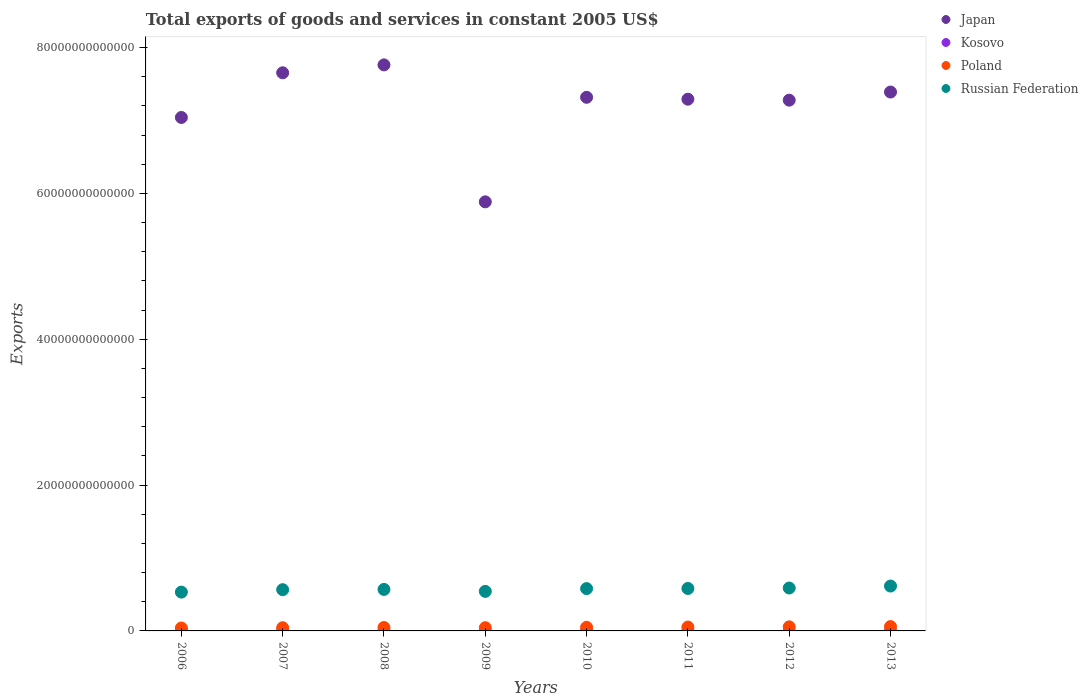What is the total exports of goods and services in Poland in 2009?
Ensure brevity in your answer.  4.40e+11. Across all years, what is the maximum total exports of goods and services in Poland?
Provide a succinct answer. 5.94e+11. Across all years, what is the minimum total exports of goods and services in Kosovo?
Offer a very short reply. 4.81e+08. In which year was the total exports of goods and services in Japan maximum?
Your answer should be very brief. 2008. In which year was the total exports of goods and services in Kosovo minimum?
Keep it short and to the point. 2006. What is the total total exports of goods and services in Russian Federation in the graph?
Make the answer very short. 4.58e+13. What is the difference between the total exports of goods and services in Japan in 2007 and that in 2009?
Give a very brief answer. 1.77e+13. What is the difference between the total exports of goods and services in Japan in 2006 and the total exports of goods and services in Russian Federation in 2010?
Your response must be concise. 6.46e+13. What is the average total exports of goods and services in Poland per year?
Offer a very short reply. 4.91e+11. In the year 2007, what is the difference between the total exports of goods and services in Japan and total exports of goods and services in Russian Federation?
Ensure brevity in your answer.  7.09e+13. In how many years, is the total exports of goods and services in Kosovo greater than 16000000000000 US$?
Offer a very short reply. 0. What is the ratio of the total exports of goods and services in Poland in 2007 to that in 2008?
Keep it short and to the point. 0.93. Is the total exports of goods and services in Poland in 2009 less than that in 2013?
Provide a short and direct response. Yes. Is the difference between the total exports of goods and services in Japan in 2008 and 2011 greater than the difference between the total exports of goods and services in Russian Federation in 2008 and 2011?
Your answer should be compact. Yes. What is the difference between the highest and the second highest total exports of goods and services in Poland?
Offer a very short reply. 3.41e+1. What is the difference between the highest and the lowest total exports of goods and services in Japan?
Make the answer very short. 1.88e+13. Is the sum of the total exports of goods and services in Poland in 2006 and 2013 greater than the maximum total exports of goods and services in Japan across all years?
Ensure brevity in your answer.  No. Is it the case that in every year, the sum of the total exports of goods and services in Japan and total exports of goods and services in Poland  is greater than the sum of total exports of goods and services in Russian Federation and total exports of goods and services in Kosovo?
Your answer should be compact. Yes. How many years are there in the graph?
Ensure brevity in your answer.  8. What is the difference between two consecutive major ticks on the Y-axis?
Your answer should be compact. 2.00e+13. Are the values on the major ticks of Y-axis written in scientific E-notation?
Ensure brevity in your answer.  No. Does the graph contain any zero values?
Keep it short and to the point. No. Where does the legend appear in the graph?
Keep it short and to the point. Top right. How many legend labels are there?
Keep it short and to the point. 4. How are the legend labels stacked?
Your answer should be very brief. Vertical. What is the title of the graph?
Keep it short and to the point. Total exports of goods and services in constant 2005 US$. What is the label or title of the X-axis?
Make the answer very short. Years. What is the label or title of the Y-axis?
Your response must be concise. Exports. What is the Exports of Japan in 2006?
Your answer should be very brief. 7.04e+13. What is the Exports of Kosovo in 2006?
Provide a succinct answer. 4.81e+08. What is the Exports of Poland in 2006?
Provide a succinct answer. 3.98e+11. What is the Exports of Russian Federation in 2006?
Provide a succinct answer. 5.32e+12. What is the Exports in Japan in 2007?
Your answer should be compact. 7.65e+13. What is the Exports in Kosovo in 2007?
Your answer should be very brief. 6.08e+08. What is the Exports of Poland in 2007?
Offer a terse response. 4.38e+11. What is the Exports in Russian Federation in 2007?
Offer a very short reply. 5.66e+12. What is the Exports of Japan in 2008?
Offer a terse response. 7.76e+13. What is the Exports in Kosovo in 2008?
Offer a very short reply. 6.09e+08. What is the Exports of Poland in 2008?
Offer a terse response. 4.69e+11. What is the Exports of Russian Federation in 2008?
Offer a very short reply. 5.69e+12. What is the Exports of Japan in 2009?
Offer a terse response. 5.88e+13. What is the Exports of Kosovo in 2009?
Provide a succinct answer. 6.85e+08. What is the Exports in Poland in 2009?
Your response must be concise. 4.40e+11. What is the Exports in Russian Federation in 2009?
Provide a succinct answer. 5.42e+12. What is the Exports of Japan in 2010?
Give a very brief answer. 7.32e+13. What is the Exports in Kosovo in 2010?
Give a very brief answer. 7.70e+08. What is the Exports in Poland in 2010?
Make the answer very short. 4.96e+11. What is the Exports of Russian Federation in 2010?
Offer a terse response. 5.80e+12. What is the Exports of Japan in 2011?
Your response must be concise. 7.29e+13. What is the Exports of Kosovo in 2011?
Provide a short and direct response. 8.00e+08. What is the Exports in Poland in 2011?
Provide a succinct answer. 5.35e+11. What is the Exports in Russian Federation in 2011?
Make the answer very short. 5.82e+12. What is the Exports in Japan in 2012?
Ensure brevity in your answer.  7.28e+13. What is the Exports in Kosovo in 2012?
Give a very brief answer. 8.06e+08. What is the Exports of Poland in 2012?
Provide a short and direct response. 5.60e+11. What is the Exports in Russian Federation in 2012?
Provide a succinct answer. 5.88e+12. What is the Exports of Japan in 2013?
Keep it short and to the point. 7.39e+13. What is the Exports of Kosovo in 2013?
Keep it short and to the point. 8.24e+08. What is the Exports in Poland in 2013?
Give a very brief answer. 5.94e+11. What is the Exports of Russian Federation in 2013?
Offer a terse response. 6.16e+12. Across all years, what is the maximum Exports of Japan?
Offer a very short reply. 7.76e+13. Across all years, what is the maximum Exports of Kosovo?
Offer a terse response. 8.24e+08. Across all years, what is the maximum Exports in Poland?
Your response must be concise. 5.94e+11. Across all years, what is the maximum Exports in Russian Federation?
Provide a succinct answer. 6.16e+12. Across all years, what is the minimum Exports in Japan?
Ensure brevity in your answer.  5.88e+13. Across all years, what is the minimum Exports of Kosovo?
Provide a short and direct response. 4.81e+08. Across all years, what is the minimum Exports in Poland?
Provide a succinct answer. 3.98e+11. Across all years, what is the minimum Exports of Russian Federation?
Your answer should be very brief. 5.32e+12. What is the total Exports of Japan in the graph?
Keep it short and to the point. 5.76e+14. What is the total Exports in Kosovo in the graph?
Keep it short and to the point. 5.58e+09. What is the total Exports in Poland in the graph?
Offer a terse response. 3.93e+12. What is the total Exports of Russian Federation in the graph?
Offer a very short reply. 4.58e+13. What is the difference between the Exports of Japan in 2006 and that in 2007?
Ensure brevity in your answer.  -6.13e+12. What is the difference between the Exports of Kosovo in 2006 and that in 2007?
Ensure brevity in your answer.  -1.27e+08. What is the difference between the Exports in Poland in 2006 and that in 2007?
Provide a short and direct response. -4.05e+1. What is the difference between the Exports in Russian Federation in 2006 and that in 2007?
Provide a succinct answer. -3.35e+11. What is the difference between the Exports in Japan in 2006 and that in 2008?
Provide a succinct answer. -7.21e+12. What is the difference between the Exports in Kosovo in 2006 and that in 2008?
Provide a short and direct response. -1.28e+08. What is the difference between the Exports of Poland in 2006 and that in 2008?
Your answer should be very brief. -7.13e+1. What is the difference between the Exports of Russian Federation in 2006 and that in 2008?
Give a very brief answer. -3.69e+11. What is the difference between the Exports in Japan in 2006 and that in 2009?
Make the answer very short. 1.16e+13. What is the difference between the Exports in Kosovo in 2006 and that in 2009?
Offer a terse response. -2.03e+08. What is the difference between the Exports of Poland in 2006 and that in 2009?
Provide a succinct answer. -4.18e+1. What is the difference between the Exports in Russian Federation in 2006 and that in 2009?
Your response must be concise. -1.02e+11. What is the difference between the Exports in Japan in 2006 and that in 2010?
Your answer should be compact. -2.76e+12. What is the difference between the Exports of Kosovo in 2006 and that in 2010?
Offer a very short reply. -2.89e+08. What is the difference between the Exports in Poland in 2006 and that in 2010?
Give a very brief answer. -9.83e+1. What is the difference between the Exports in Russian Federation in 2006 and that in 2010?
Your answer should be very brief. -4.81e+11. What is the difference between the Exports of Japan in 2006 and that in 2011?
Provide a succinct answer. -2.50e+12. What is the difference between the Exports of Kosovo in 2006 and that in 2011?
Your answer should be compact. -3.19e+08. What is the difference between the Exports of Poland in 2006 and that in 2011?
Your response must be concise. -1.37e+11. What is the difference between the Exports in Russian Federation in 2006 and that in 2011?
Provide a succinct answer. -4.99e+11. What is the difference between the Exports in Japan in 2006 and that in 2012?
Offer a very short reply. -2.37e+12. What is the difference between the Exports in Kosovo in 2006 and that in 2012?
Give a very brief answer. -3.24e+08. What is the difference between the Exports in Poland in 2006 and that in 2012?
Your answer should be very brief. -1.62e+11. What is the difference between the Exports in Russian Federation in 2006 and that in 2012?
Provide a succinct answer. -5.63e+11. What is the difference between the Exports in Japan in 2006 and that in 2013?
Your answer should be compact. -3.49e+12. What is the difference between the Exports of Kosovo in 2006 and that in 2013?
Your answer should be compact. -3.43e+08. What is the difference between the Exports in Poland in 2006 and that in 2013?
Offer a terse response. -1.96e+11. What is the difference between the Exports in Russian Federation in 2006 and that in 2013?
Give a very brief answer. -8.34e+11. What is the difference between the Exports of Japan in 2007 and that in 2008?
Offer a terse response. -1.08e+12. What is the difference between the Exports of Kosovo in 2007 and that in 2008?
Give a very brief answer. -5.00e+05. What is the difference between the Exports in Poland in 2007 and that in 2008?
Ensure brevity in your answer.  -3.07e+1. What is the difference between the Exports of Russian Federation in 2007 and that in 2008?
Your answer should be very brief. -3.39e+1. What is the difference between the Exports in Japan in 2007 and that in 2009?
Offer a terse response. 1.77e+13. What is the difference between the Exports of Kosovo in 2007 and that in 2009?
Give a very brief answer. -7.64e+07. What is the difference between the Exports of Poland in 2007 and that in 2009?
Keep it short and to the point. -1.27e+09. What is the difference between the Exports of Russian Federation in 2007 and that in 2009?
Provide a succinct answer. 2.34e+11. What is the difference between the Exports in Japan in 2007 and that in 2010?
Provide a short and direct response. 3.36e+12. What is the difference between the Exports of Kosovo in 2007 and that in 2010?
Your response must be concise. -1.62e+08. What is the difference between the Exports in Poland in 2007 and that in 2010?
Your response must be concise. -5.78e+1. What is the difference between the Exports in Russian Federation in 2007 and that in 2010?
Provide a short and direct response. -1.46e+11. What is the difference between the Exports of Japan in 2007 and that in 2011?
Your answer should be compact. 3.62e+12. What is the difference between the Exports of Kosovo in 2007 and that in 2011?
Give a very brief answer. -1.92e+08. What is the difference between the Exports in Poland in 2007 and that in 2011?
Your answer should be very brief. -9.68e+1. What is the difference between the Exports in Russian Federation in 2007 and that in 2011?
Give a very brief answer. -1.64e+11. What is the difference between the Exports in Japan in 2007 and that in 2012?
Ensure brevity in your answer.  3.75e+12. What is the difference between the Exports in Kosovo in 2007 and that in 2012?
Your answer should be very brief. -1.97e+08. What is the difference between the Exports of Poland in 2007 and that in 2012?
Offer a terse response. -1.21e+11. What is the difference between the Exports of Russian Federation in 2007 and that in 2012?
Make the answer very short. -2.28e+11. What is the difference between the Exports of Japan in 2007 and that in 2013?
Offer a terse response. 2.64e+12. What is the difference between the Exports in Kosovo in 2007 and that in 2013?
Offer a terse response. -2.16e+08. What is the difference between the Exports in Poland in 2007 and that in 2013?
Offer a very short reply. -1.55e+11. What is the difference between the Exports in Russian Federation in 2007 and that in 2013?
Provide a succinct answer. -4.98e+11. What is the difference between the Exports in Japan in 2008 and that in 2009?
Ensure brevity in your answer.  1.88e+13. What is the difference between the Exports of Kosovo in 2008 and that in 2009?
Provide a succinct answer. -7.59e+07. What is the difference between the Exports in Poland in 2008 and that in 2009?
Your answer should be compact. 2.95e+1. What is the difference between the Exports of Russian Federation in 2008 and that in 2009?
Provide a succinct answer. 2.67e+11. What is the difference between the Exports of Japan in 2008 and that in 2010?
Your answer should be compact. 4.45e+12. What is the difference between the Exports of Kosovo in 2008 and that in 2010?
Make the answer very short. -1.62e+08. What is the difference between the Exports of Poland in 2008 and that in 2010?
Give a very brief answer. -2.71e+1. What is the difference between the Exports in Russian Federation in 2008 and that in 2010?
Make the answer very short. -1.12e+11. What is the difference between the Exports in Japan in 2008 and that in 2011?
Your response must be concise. 4.71e+12. What is the difference between the Exports of Kosovo in 2008 and that in 2011?
Provide a short and direct response. -1.91e+08. What is the difference between the Exports of Poland in 2008 and that in 2011?
Give a very brief answer. -6.61e+1. What is the difference between the Exports in Russian Federation in 2008 and that in 2011?
Provide a succinct answer. -1.30e+11. What is the difference between the Exports of Japan in 2008 and that in 2012?
Provide a short and direct response. 4.84e+12. What is the difference between the Exports in Kosovo in 2008 and that in 2012?
Offer a terse response. -1.97e+08. What is the difference between the Exports of Poland in 2008 and that in 2012?
Your answer should be very brief. -9.06e+1. What is the difference between the Exports of Russian Federation in 2008 and that in 2012?
Offer a very short reply. -1.94e+11. What is the difference between the Exports in Japan in 2008 and that in 2013?
Your answer should be compact. 3.72e+12. What is the difference between the Exports of Kosovo in 2008 and that in 2013?
Your answer should be compact. -2.15e+08. What is the difference between the Exports of Poland in 2008 and that in 2013?
Your response must be concise. -1.25e+11. What is the difference between the Exports in Russian Federation in 2008 and that in 2013?
Offer a very short reply. -4.64e+11. What is the difference between the Exports of Japan in 2009 and that in 2010?
Offer a very short reply. -1.43e+13. What is the difference between the Exports of Kosovo in 2009 and that in 2010?
Ensure brevity in your answer.  -8.56e+07. What is the difference between the Exports of Poland in 2009 and that in 2010?
Your answer should be compact. -5.65e+1. What is the difference between the Exports in Russian Federation in 2009 and that in 2010?
Ensure brevity in your answer.  -3.80e+11. What is the difference between the Exports of Japan in 2009 and that in 2011?
Your response must be concise. -1.41e+13. What is the difference between the Exports in Kosovo in 2009 and that in 2011?
Provide a short and direct response. -1.15e+08. What is the difference between the Exports of Poland in 2009 and that in 2011?
Make the answer very short. -9.55e+1. What is the difference between the Exports in Russian Federation in 2009 and that in 2011?
Your answer should be very brief. -3.97e+11. What is the difference between the Exports of Japan in 2009 and that in 2012?
Make the answer very short. -1.39e+13. What is the difference between the Exports of Kosovo in 2009 and that in 2012?
Provide a short and direct response. -1.21e+08. What is the difference between the Exports in Poland in 2009 and that in 2012?
Ensure brevity in your answer.  -1.20e+11. What is the difference between the Exports in Russian Federation in 2009 and that in 2012?
Give a very brief answer. -4.61e+11. What is the difference between the Exports of Japan in 2009 and that in 2013?
Keep it short and to the point. -1.51e+13. What is the difference between the Exports of Kosovo in 2009 and that in 2013?
Your response must be concise. -1.39e+08. What is the difference between the Exports of Poland in 2009 and that in 2013?
Provide a short and direct response. -1.54e+11. What is the difference between the Exports of Russian Federation in 2009 and that in 2013?
Offer a very short reply. -7.32e+11. What is the difference between the Exports of Japan in 2010 and that in 2011?
Your answer should be very brief. 2.60e+11. What is the difference between the Exports in Kosovo in 2010 and that in 2011?
Provide a short and direct response. -2.96e+07. What is the difference between the Exports of Poland in 2010 and that in 2011?
Ensure brevity in your answer.  -3.90e+1. What is the difference between the Exports of Russian Federation in 2010 and that in 2011?
Your answer should be compact. -1.74e+1. What is the difference between the Exports of Japan in 2010 and that in 2012?
Provide a succinct answer. 3.92e+11. What is the difference between the Exports in Kosovo in 2010 and that in 2012?
Provide a short and direct response. -3.52e+07. What is the difference between the Exports in Poland in 2010 and that in 2012?
Make the answer very short. -6.35e+1. What is the difference between the Exports in Russian Federation in 2010 and that in 2012?
Offer a very short reply. -8.14e+1. What is the difference between the Exports in Japan in 2010 and that in 2013?
Provide a short and direct response. -7.21e+11. What is the difference between the Exports of Kosovo in 2010 and that in 2013?
Offer a very short reply. -5.38e+07. What is the difference between the Exports of Poland in 2010 and that in 2013?
Your answer should be very brief. -9.76e+1. What is the difference between the Exports of Russian Federation in 2010 and that in 2013?
Offer a terse response. -3.52e+11. What is the difference between the Exports in Japan in 2011 and that in 2012?
Your answer should be very brief. 1.32e+11. What is the difference between the Exports of Kosovo in 2011 and that in 2012?
Ensure brevity in your answer.  -5.60e+06. What is the difference between the Exports of Poland in 2011 and that in 2012?
Give a very brief answer. -2.45e+1. What is the difference between the Exports in Russian Federation in 2011 and that in 2012?
Give a very brief answer. -6.40e+1. What is the difference between the Exports of Japan in 2011 and that in 2013?
Your response must be concise. -9.81e+11. What is the difference between the Exports in Kosovo in 2011 and that in 2013?
Offer a very short reply. -2.42e+07. What is the difference between the Exports in Poland in 2011 and that in 2013?
Your answer should be very brief. -5.86e+1. What is the difference between the Exports of Russian Federation in 2011 and that in 2013?
Your answer should be very brief. -3.35e+11. What is the difference between the Exports of Japan in 2012 and that in 2013?
Give a very brief answer. -1.11e+12. What is the difference between the Exports of Kosovo in 2012 and that in 2013?
Offer a terse response. -1.86e+07. What is the difference between the Exports in Poland in 2012 and that in 2013?
Your answer should be compact. -3.41e+1. What is the difference between the Exports of Russian Federation in 2012 and that in 2013?
Provide a succinct answer. -2.71e+11. What is the difference between the Exports of Japan in 2006 and the Exports of Kosovo in 2007?
Keep it short and to the point. 7.04e+13. What is the difference between the Exports of Japan in 2006 and the Exports of Poland in 2007?
Offer a very short reply. 7.00e+13. What is the difference between the Exports of Japan in 2006 and the Exports of Russian Federation in 2007?
Your answer should be compact. 6.48e+13. What is the difference between the Exports of Kosovo in 2006 and the Exports of Poland in 2007?
Your answer should be very brief. -4.38e+11. What is the difference between the Exports in Kosovo in 2006 and the Exports in Russian Federation in 2007?
Keep it short and to the point. -5.66e+12. What is the difference between the Exports in Poland in 2006 and the Exports in Russian Federation in 2007?
Give a very brief answer. -5.26e+12. What is the difference between the Exports of Japan in 2006 and the Exports of Kosovo in 2008?
Your answer should be very brief. 7.04e+13. What is the difference between the Exports of Japan in 2006 and the Exports of Poland in 2008?
Give a very brief answer. 6.99e+13. What is the difference between the Exports of Japan in 2006 and the Exports of Russian Federation in 2008?
Keep it short and to the point. 6.47e+13. What is the difference between the Exports in Kosovo in 2006 and the Exports in Poland in 2008?
Make the answer very short. -4.69e+11. What is the difference between the Exports in Kosovo in 2006 and the Exports in Russian Federation in 2008?
Make the answer very short. -5.69e+12. What is the difference between the Exports in Poland in 2006 and the Exports in Russian Federation in 2008?
Provide a succinct answer. -5.29e+12. What is the difference between the Exports in Japan in 2006 and the Exports in Kosovo in 2009?
Provide a short and direct response. 7.04e+13. What is the difference between the Exports in Japan in 2006 and the Exports in Poland in 2009?
Provide a succinct answer. 7.00e+13. What is the difference between the Exports of Japan in 2006 and the Exports of Russian Federation in 2009?
Offer a very short reply. 6.50e+13. What is the difference between the Exports in Kosovo in 2006 and the Exports in Poland in 2009?
Offer a terse response. -4.39e+11. What is the difference between the Exports in Kosovo in 2006 and the Exports in Russian Federation in 2009?
Keep it short and to the point. -5.42e+12. What is the difference between the Exports in Poland in 2006 and the Exports in Russian Federation in 2009?
Your answer should be compact. -5.03e+12. What is the difference between the Exports in Japan in 2006 and the Exports in Kosovo in 2010?
Give a very brief answer. 7.04e+13. What is the difference between the Exports of Japan in 2006 and the Exports of Poland in 2010?
Keep it short and to the point. 6.99e+13. What is the difference between the Exports of Japan in 2006 and the Exports of Russian Federation in 2010?
Provide a succinct answer. 6.46e+13. What is the difference between the Exports in Kosovo in 2006 and the Exports in Poland in 2010?
Your response must be concise. -4.96e+11. What is the difference between the Exports in Kosovo in 2006 and the Exports in Russian Federation in 2010?
Provide a succinct answer. -5.80e+12. What is the difference between the Exports of Poland in 2006 and the Exports of Russian Federation in 2010?
Keep it short and to the point. -5.41e+12. What is the difference between the Exports in Japan in 2006 and the Exports in Kosovo in 2011?
Make the answer very short. 7.04e+13. What is the difference between the Exports in Japan in 2006 and the Exports in Poland in 2011?
Offer a very short reply. 6.99e+13. What is the difference between the Exports of Japan in 2006 and the Exports of Russian Federation in 2011?
Provide a succinct answer. 6.46e+13. What is the difference between the Exports of Kosovo in 2006 and the Exports of Poland in 2011?
Your answer should be compact. -5.35e+11. What is the difference between the Exports of Kosovo in 2006 and the Exports of Russian Federation in 2011?
Your answer should be very brief. -5.82e+12. What is the difference between the Exports of Poland in 2006 and the Exports of Russian Federation in 2011?
Provide a succinct answer. -5.42e+12. What is the difference between the Exports in Japan in 2006 and the Exports in Kosovo in 2012?
Offer a terse response. 7.04e+13. What is the difference between the Exports in Japan in 2006 and the Exports in Poland in 2012?
Your answer should be compact. 6.99e+13. What is the difference between the Exports in Japan in 2006 and the Exports in Russian Federation in 2012?
Make the answer very short. 6.45e+13. What is the difference between the Exports in Kosovo in 2006 and the Exports in Poland in 2012?
Ensure brevity in your answer.  -5.59e+11. What is the difference between the Exports in Kosovo in 2006 and the Exports in Russian Federation in 2012?
Your answer should be very brief. -5.88e+12. What is the difference between the Exports in Poland in 2006 and the Exports in Russian Federation in 2012?
Your answer should be compact. -5.49e+12. What is the difference between the Exports in Japan in 2006 and the Exports in Kosovo in 2013?
Provide a succinct answer. 7.04e+13. What is the difference between the Exports of Japan in 2006 and the Exports of Poland in 2013?
Keep it short and to the point. 6.98e+13. What is the difference between the Exports in Japan in 2006 and the Exports in Russian Federation in 2013?
Make the answer very short. 6.43e+13. What is the difference between the Exports of Kosovo in 2006 and the Exports of Poland in 2013?
Make the answer very short. -5.93e+11. What is the difference between the Exports of Kosovo in 2006 and the Exports of Russian Federation in 2013?
Provide a short and direct response. -6.16e+12. What is the difference between the Exports in Poland in 2006 and the Exports in Russian Federation in 2013?
Provide a succinct answer. -5.76e+12. What is the difference between the Exports in Japan in 2007 and the Exports in Kosovo in 2008?
Keep it short and to the point. 7.65e+13. What is the difference between the Exports of Japan in 2007 and the Exports of Poland in 2008?
Ensure brevity in your answer.  7.61e+13. What is the difference between the Exports in Japan in 2007 and the Exports in Russian Federation in 2008?
Keep it short and to the point. 7.09e+13. What is the difference between the Exports in Kosovo in 2007 and the Exports in Poland in 2008?
Provide a succinct answer. -4.68e+11. What is the difference between the Exports in Kosovo in 2007 and the Exports in Russian Federation in 2008?
Your answer should be very brief. -5.69e+12. What is the difference between the Exports in Poland in 2007 and the Exports in Russian Federation in 2008?
Provide a succinct answer. -5.25e+12. What is the difference between the Exports in Japan in 2007 and the Exports in Kosovo in 2009?
Ensure brevity in your answer.  7.65e+13. What is the difference between the Exports of Japan in 2007 and the Exports of Poland in 2009?
Give a very brief answer. 7.61e+13. What is the difference between the Exports of Japan in 2007 and the Exports of Russian Federation in 2009?
Offer a very short reply. 7.11e+13. What is the difference between the Exports of Kosovo in 2007 and the Exports of Poland in 2009?
Ensure brevity in your answer.  -4.39e+11. What is the difference between the Exports in Kosovo in 2007 and the Exports in Russian Federation in 2009?
Keep it short and to the point. -5.42e+12. What is the difference between the Exports of Poland in 2007 and the Exports of Russian Federation in 2009?
Your answer should be very brief. -4.99e+12. What is the difference between the Exports in Japan in 2007 and the Exports in Kosovo in 2010?
Offer a very short reply. 7.65e+13. What is the difference between the Exports of Japan in 2007 and the Exports of Poland in 2010?
Your answer should be very brief. 7.60e+13. What is the difference between the Exports in Japan in 2007 and the Exports in Russian Federation in 2010?
Ensure brevity in your answer.  7.07e+13. What is the difference between the Exports in Kosovo in 2007 and the Exports in Poland in 2010?
Give a very brief answer. -4.95e+11. What is the difference between the Exports in Kosovo in 2007 and the Exports in Russian Federation in 2010?
Your answer should be compact. -5.80e+12. What is the difference between the Exports of Poland in 2007 and the Exports of Russian Federation in 2010?
Keep it short and to the point. -5.37e+12. What is the difference between the Exports in Japan in 2007 and the Exports in Kosovo in 2011?
Offer a very short reply. 7.65e+13. What is the difference between the Exports in Japan in 2007 and the Exports in Poland in 2011?
Offer a terse response. 7.60e+13. What is the difference between the Exports of Japan in 2007 and the Exports of Russian Federation in 2011?
Offer a very short reply. 7.07e+13. What is the difference between the Exports of Kosovo in 2007 and the Exports of Poland in 2011?
Your answer should be very brief. -5.34e+11. What is the difference between the Exports of Kosovo in 2007 and the Exports of Russian Federation in 2011?
Offer a very short reply. -5.82e+12. What is the difference between the Exports in Poland in 2007 and the Exports in Russian Federation in 2011?
Ensure brevity in your answer.  -5.38e+12. What is the difference between the Exports of Japan in 2007 and the Exports of Kosovo in 2012?
Offer a terse response. 7.65e+13. What is the difference between the Exports of Japan in 2007 and the Exports of Poland in 2012?
Your response must be concise. 7.60e+13. What is the difference between the Exports in Japan in 2007 and the Exports in Russian Federation in 2012?
Give a very brief answer. 7.07e+13. What is the difference between the Exports of Kosovo in 2007 and the Exports of Poland in 2012?
Offer a terse response. -5.59e+11. What is the difference between the Exports in Kosovo in 2007 and the Exports in Russian Federation in 2012?
Your response must be concise. -5.88e+12. What is the difference between the Exports in Poland in 2007 and the Exports in Russian Federation in 2012?
Provide a short and direct response. -5.45e+12. What is the difference between the Exports in Japan in 2007 and the Exports in Kosovo in 2013?
Your answer should be very brief. 7.65e+13. What is the difference between the Exports of Japan in 2007 and the Exports of Poland in 2013?
Your response must be concise. 7.60e+13. What is the difference between the Exports of Japan in 2007 and the Exports of Russian Federation in 2013?
Give a very brief answer. 7.04e+13. What is the difference between the Exports of Kosovo in 2007 and the Exports of Poland in 2013?
Provide a short and direct response. -5.93e+11. What is the difference between the Exports of Kosovo in 2007 and the Exports of Russian Federation in 2013?
Offer a very short reply. -6.16e+12. What is the difference between the Exports of Poland in 2007 and the Exports of Russian Federation in 2013?
Provide a succinct answer. -5.72e+12. What is the difference between the Exports of Japan in 2008 and the Exports of Kosovo in 2009?
Make the answer very short. 7.76e+13. What is the difference between the Exports in Japan in 2008 and the Exports in Poland in 2009?
Your answer should be compact. 7.72e+13. What is the difference between the Exports of Japan in 2008 and the Exports of Russian Federation in 2009?
Your answer should be compact. 7.22e+13. What is the difference between the Exports of Kosovo in 2008 and the Exports of Poland in 2009?
Your answer should be compact. -4.39e+11. What is the difference between the Exports of Kosovo in 2008 and the Exports of Russian Federation in 2009?
Your answer should be very brief. -5.42e+12. What is the difference between the Exports of Poland in 2008 and the Exports of Russian Federation in 2009?
Offer a terse response. -4.95e+12. What is the difference between the Exports in Japan in 2008 and the Exports in Kosovo in 2010?
Provide a short and direct response. 7.76e+13. What is the difference between the Exports in Japan in 2008 and the Exports in Poland in 2010?
Give a very brief answer. 7.71e+13. What is the difference between the Exports of Japan in 2008 and the Exports of Russian Federation in 2010?
Give a very brief answer. 7.18e+13. What is the difference between the Exports in Kosovo in 2008 and the Exports in Poland in 2010?
Offer a terse response. -4.95e+11. What is the difference between the Exports of Kosovo in 2008 and the Exports of Russian Federation in 2010?
Provide a succinct answer. -5.80e+12. What is the difference between the Exports of Poland in 2008 and the Exports of Russian Federation in 2010?
Give a very brief answer. -5.33e+12. What is the difference between the Exports of Japan in 2008 and the Exports of Kosovo in 2011?
Provide a short and direct response. 7.76e+13. What is the difference between the Exports in Japan in 2008 and the Exports in Poland in 2011?
Provide a succinct answer. 7.71e+13. What is the difference between the Exports of Japan in 2008 and the Exports of Russian Federation in 2011?
Provide a short and direct response. 7.18e+13. What is the difference between the Exports in Kosovo in 2008 and the Exports in Poland in 2011?
Your answer should be compact. -5.34e+11. What is the difference between the Exports in Kosovo in 2008 and the Exports in Russian Federation in 2011?
Make the answer very short. -5.82e+12. What is the difference between the Exports in Poland in 2008 and the Exports in Russian Federation in 2011?
Your answer should be very brief. -5.35e+12. What is the difference between the Exports of Japan in 2008 and the Exports of Kosovo in 2012?
Your answer should be compact. 7.76e+13. What is the difference between the Exports of Japan in 2008 and the Exports of Poland in 2012?
Offer a very short reply. 7.71e+13. What is the difference between the Exports in Japan in 2008 and the Exports in Russian Federation in 2012?
Make the answer very short. 7.17e+13. What is the difference between the Exports in Kosovo in 2008 and the Exports in Poland in 2012?
Make the answer very short. -5.59e+11. What is the difference between the Exports of Kosovo in 2008 and the Exports of Russian Federation in 2012?
Your answer should be very brief. -5.88e+12. What is the difference between the Exports in Poland in 2008 and the Exports in Russian Federation in 2012?
Your answer should be very brief. -5.42e+12. What is the difference between the Exports in Japan in 2008 and the Exports in Kosovo in 2013?
Your answer should be very brief. 7.76e+13. What is the difference between the Exports in Japan in 2008 and the Exports in Poland in 2013?
Offer a very short reply. 7.70e+13. What is the difference between the Exports in Japan in 2008 and the Exports in Russian Federation in 2013?
Give a very brief answer. 7.15e+13. What is the difference between the Exports in Kosovo in 2008 and the Exports in Poland in 2013?
Make the answer very short. -5.93e+11. What is the difference between the Exports of Kosovo in 2008 and the Exports of Russian Federation in 2013?
Your answer should be very brief. -6.16e+12. What is the difference between the Exports in Poland in 2008 and the Exports in Russian Federation in 2013?
Keep it short and to the point. -5.69e+12. What is the difference between the Exports of Japan in 2009 and the Exports of Kosovo in 2010?
Give a very brief answer. 5.88e+13. What is the difference between the Exports of Japan in 2009 and the Exports of Poland in 2010?
Provide a succinct answer. 5.83e+13. What is the difference between the Exports in Japan in 2009 and the Exports in Russian Federation in 2010?
Offer a terse response. 5.30e+13. What is the difference between the Exports in Kosovo in 2009 and the Exports in Poland in 2010?
Offer a very short reply. -4.95e+11. What is the difference between the Exports in Kosovo in 2009 and the Exports in Russian Federation in 2010?
Make the answer very short. -5.80e+12. What is the difference between the Exports in Poland in 2009 and the Exports in Russian Federation in 2010?
Offer a very short reply. -5.36e+12. What is the difference between the Exports in Japan in 2009 and the Exports in Kosovo in 2011?
Make the answer very short. 5.88e+13. What is the difference between the Exports of Japan in 2009 and the Exports of Poland in 2011?
Your response must be concise. 5.83e+13. What is the difference between the Exports of Japan in 2009 and the Exports of Russian Federation in 2011?
Your response must be concise. 5.30e+13. What is the difference between the Exports in Kosovo in 2009 and the Exports in Poland in 2011?
Ensure brevity in your answer.  -5.34e+11. What is the difference between the Exports of Kosovo in 2009 and the Exports of Russian Federation in 2011?
Offer a very short reply. -5.82e+12. What is the difference between the Exports of Poland in 2009 and the Exports of Russian Federation in 2011?
Provide a succinct answer. -5.38e+12. What is the difference between the Exports in Japan in 2009 and the Exports in Kosovo in 2012?
Provide a succinct answer. 5.88e+13. What is the difference between the Exports in Japan in 2009 and the Exports in Poland in 2012?
Make the answer very short. 5.83e+13. What is the difference between the Exports of Japan in 2009 and the Exports of Russian Federation in 2012?
Offer a terse response. 5.30e+13. What is the difference between the Exports of Kosovo in 2009 and the Exports of Poland in 2012?
Your answer should be very brief. -5.59e+11. What is the difference between the Exports of Kosovo in 2009 and the Exports of Russian Federation in 2012?
Give a very brief answer. -5.88e+12. What is the difference between the Exports of Poland in 2009 and the Exports of Russian Federation in 2012?
Make the answer very short. -5.45e+12. What is the difference between the Exports of Japan in 2009 and the Exports of Kosovo in 2013?
Make the answer very short. 5.88e+13. What is the difference between the Exports in Japan in 2009 and the Exports in Poland in 2013?
Your answer should be compact. 5.83e+13. What is the difference between the Exports in Japan in 2009 and the Exports in Russian Federation in 2013?
Offer a terse response. 5.27e+13. What is the difference between the Exports of Kosovo in 2009 and the Exports of Poland in 2013?
Provide a succinct answer. -5.93e+11. What is the difference between the Exports of Kosovo in 2009 and the Exports of Russian Federation in 2013?
Ensure brevity in your answer.  -6.15e+12. What is the difference between the Exports of Poland in 2009 and the Exports of Russian Federation in 2013?
Your answer should be compact. -5.72e+12. What is the difference between the Exports of Japan in 2010 and the Exports of Kosovo in 2011?
Your response must be concise. 7.32e+13. What is the difference between the Exports in Japan in 2010 and the Exports in Poland in 2011?
Your response must be concise. 7.26e+13. What is the difference between the Exports in Japan in 2010 and the Exports in Russian Federation in 2011?
Ensure brevity in your answer.  6.74e+13. What is the difference between the Exports in Kosovo in 2010 and the Exports in Poland in 2011?
Offer a terse response. -5.34e+11. What is the difference between the Exports of Kosovo in 2010 and the Exports of Russian Federation in 2011?
Keep it short and to the point. -5.82e+12. What is the difference between the Exports in Poland in 2010 and the Exports in Russian Federation in 2011?
Offer a very short reply. -5.32e+12. What is the difference between the Exports of Japan in 2010 and the Exports of Kosovo in 2012?
Offer a terse response. 7.32e+13. What is the difference between the Exports of Japan in 2010 and the Exports of Poland in 2012?
Your answer should be very brief. 7.26e+13. What is the difference between the Exports in Japan in 2010 and the Exports in Russian Federation in 2012?
Make the answer very short. 6.73e+13. What is the difference between the Exports in Kosovo in 2010 and the Exports in Poland in 2012?
Ensure brevity in your answer.  -5.59e+11. What is the difference between the Exports in Kosovo in 2010 and the Exports in Russian Federation in 2012?
Provide a short and direct response. -5.88e+12. What is the difference between the Exports of Poland in 2010 and the Exports of Russian Federation in 2012?
Provide a short and direct response. -5.39e+12. What is the difference between the Exports in Japan in 2010 and the Exports in Kosovo in 2013?
Give a very brief answer. 7.32e+13. What is the difference between the Exports in Japan in 2010 and the Exports in Poland in 2013?
Provide a succinct answer. 7.26e+13. What is the difference between the Exports of Japan in 2010 and the Exports of Russian Federation in 2013?
Your response must be concise. 6.70e+13. What is the difference between the Exports in Kosovo in 2010 and the Exports in Poland in 2013?
Ensure brevity in your answer.  -5.93e+11. What is the difference between the Exports in Kosovo in 2010 and the Exports in Russian Federation in 2013?
Offer a very short reply. -6.15e+12. What is the difference between the Exports in Poland in 2010 and the Exports in Russian Federation in 2013?
Keep it short and to the point. -5.66e+12. What is the difference between the Exports of Japan in 2011 and the Exports of Kosovo in 2012?
Your answer should be compact. 7.29e+13. What is the difference between the Exports of Japan in 2011 and the Exports of Poland in 2012?
Keep it short and to the point. 7.24e+13. What is the difference between the Exports in Japan in 2011 and the Exports in Russian Federation in 2012?
Provide a succinct answer. 6.70e+13. What is the difference between the Exports of Kosovo in 2011 and the Exports of Poland in 2012?
Offer a very short reply. -5.59e+11. What is the difference between the Exports in Kosovo in 2011 and the Exports in Russian Federation in 2012?
Provide a short and direct response. -5.88e+12. What is the difference between the Exports of Poland in 2011 and the Exports of Russian Federation in 2012?
Provide a succinct answer. -5.35e+12. What is the difference between the Exports of Japan in 2011 and the Exports of Kosovo in 2013?
Your response must be concise. 7.29e+13. What is the difference between the Exports of Japan in 2011 and the Exports of Poland in 2013?
Provide a succinct answer. 7.23e+13. What is the difference between the Exports of Japan in 2011 and the Exports of Russian Federation in 2013?
Offer a terse response. 6.68e+13. What is the difference between the Exports in Kosovo in 2011 and the Exports in Poland in 2013?
Your answer should be compact. -5.93e+11. What is the difference between the Exports of Kosovo in 2011 and the Exports of Russian Federation in 2013?
Offer a terse response. -6.15e+12. What is the difference between the Exports in Poland in 2011 and the Exports in Russian Federation in 2013?
Your answer should be compact. -5.62e+12. What is the difference between the Exports in Japan in 2012 and the Exports in Kosovo in 2013?
Your response must be concise. 7.28e+13. What is the difference between the Exports in Japan in 2012 and the Exports in Poland in 2013?
Provide a succinct answer. 7.22e+13. What is the difference between the Exports of Japan in 2012 and the Exports of Russian Federation in 2013?
Your answer should be compact. 6.66e+13. What is the difference between the Exports in Kosovo in 2012 and the Exports in Poland in 2013?
Provide a short and direct response. -5.93e+11. What is the difference between the Exports of Kosovo in 2012 and the Exports of Russian Federation in 2013?
Ensure brevity in your answer.  -6.15e+12. What is the difference between the Exports in Poland in 2012 and the Exports in Russian Federation in 2013?
Keep it short and to the point. -5.60e+12. What is the average Exports of Japan per year?
Offer a terse response. 7.20e+13. What is the average Exports in Kosovo per year?
Keep it short and to the point. 6.98e+08. What is the average Exports of Poland per year?
Ensure brevity in your answer.  4.91e+11. What is the average Exports of Russian Federation per year?
Make the answer very short. 5.72e+12. In the year 2006, what is the difference between the Exports of Japan and Exports of Kosovo?
Ensure brevity in your answer.  7.04e+13. In the year 2006, what is the difference between the Exports of Japan and Exports of Poland?
Provide a short and direct response. 7.00e+13. In the year 2006, what is the difference between the Exports in Japan and Exports in Russian Federation?
Make the answer very short. 6.51e+13. In the year 2006, what is the difference between the Exports in Kosovo and Exports in Poland?
Make the answer very short. -3.97e+11. In the year 2006, what is the difference between the Exports of Kosovo and Exports of Russian Federation?
Offer a terse response. -5.32e+12. In the year 2006, what is the difference between the Exports in Poland and Exports in Russian Federation?
Offer a terse response. -4.92e+12. In the year 2007, what is the difference between the Exports in Japan and Exports in Kosovo?
Your response must be concise. 7.65e+13. In the year 2007, what is the difference between the Exports of Japan and Exports of Poland?
Provide a short and direct response. 7.61e+13. In the year 2007, what is the difference between the Exports in Japan and Exports in Russian Federation?
Keep it short and to the point. 7.09e+13. In the year 2007, what is the difference between the Exports of Kosovo and Exports of Poland?
Ensure brevity in your answer.  -4.38e+11. In the year 2007, what is the difference between the Exports of Kosovo and Exports of Russian Federation?
Your answer should be compact. -5.66e+12. In the year 2007, what is the difference between the Exports in Poland and Exports in Russian Federation?
Your answer should be very brief. -5.22e+12. In the year 2008, what is the difference between the Exports of Japan and Exports of Kosovo?
Make the answer very short. 7.76e+13. In the year 2008, what is the difference between the Exports in Japan and Exports in Poland?
Your answer should be compact. 7.72e+13. In the year 2008, what is the difference between the Exports in Japan and Exports in Russian Federation?
Offer a very short reply. 7.19e+13. In the year 2008, what is the difference between the Exports in Kosovo and Exports in Poland?
Provide a short and direct response. -4.68e+11. In the year 2008, what is the difference between the Exports of Kosovo and Exports of Russian Federation?
Make the answer very short. -5.69e+12. In the year 2008, what is the difference between the Exports in Poland and Exports in Russian Federation?
Provide a succinct answer. -5.22e+12. In the year 2009, what is the difference between the Exports in Japan and Exports in Kosovo?
Keep it short and to the point. 5.88e+13. In the year 2009, what is the difference between the Exports in Japan and Exports in Poland?
Provide a succinct answer. 5.84e+13. In the year 2009, what is the difference between the Exports of Japan and Exports of Russian Federation?
Offer a terse response. 5.34e+13. In the year 2009, what is the difference between the Exports in Kosovo and Exports in Poland?
Your answer should be very brief. -4.39e+11. In the year 2009, what is the difference between the Exports in Kosovo and Exports in Russian Federation?
Ensure brevity in your answer.  -5.42e+12. In the year 2009, what is the difference between the Exports of Poland and Exports of Russian Federation?
Offer a terse response. -4.98e+12. In the year 2010, what is the difference between the Exports of Japan and Exports of Kosovo?
Keep it short and to the point. 7.32e+13. In the year 2010, what is the difference between the Exports in Japan and Exports in Poland?
Give a very brief answer. 7.27e+13. In the year 2010, what is the difference between the Exports in Japan and Exports in Russian Federation?
Give a very brief answer. 6.74e+13. In the year 2010, what is the difference between the Exports of Kosovo and Exports of Poland?
Your response must be concise. -4.95e+11. In the year 2010, what is the difference between the Exports in Kosovo and Exports in Russian Federation?
Your response must be concise. -5.80e+12. In the year 2010, what is the difference between the Exports in Poland and Exports in Russian Federation?
Ensure brevity in your answer.  -5.31e+12. In the year 2011, what is the difference between the Exports in Japan and Exports in Kosovo?
Offer a terse response. 7.29e+13. In the year 2011, what is the difference between the Exports of Japan and Exports of Poland?
Provide a short and direct response. 7.24e+13. In the year 2011, what is the difference between the Exports in Japan and Exports in Russian Federation?
Give a very brief answer. 6.71e+13. In the year 2011, what is the difference between the Exports of Kosovo and Exports of Poland?
Provide a succinct answer. -5.34e+11. In the year 2011, what is the difference between the Exports of Kosovo and Exports of Russian Federation?
Offer a terse response. -5.82e+12. In the year 2011, what is the difference between the Exports in Poland and Exports in Russian Federation?
Offer a very short reply. -5.29e+12. In the year 2012, what is the difference between the Exports in Japan and Exports in Kosovo?
Offer a very short reply. 7.28e+13. In the year 2012, what is the difference between the Exports in Japan and Exports in Poland?
Your answer should be very brief. 7.22e+13. In the year 2012, what is the difference between the Exports in Japan and Exports in Russian Federation?
Offer a terse response. 6.69e+13. In the year 2012, what is the difference between the Exports in Kosovo and Exports in Poland?
Provide a short and direct response. -5.59e+11. In the year 2012, what is the difference between the Exports in Kosovo and Exports in Russian Federation?
Your answer should be very brief. -5.88e+12. In the year 2012, what is the difference between the Exports in Poland and Exports in Russian Federation?
Provide a succinct answer. -5.33e+12. In the year 2013, what is the difference between the Exports in Japan and Exports in Kosovo?
Ensure brevity in your answer.  7.39e+13. In the year 2013, what is the difference between the Exports of Japan and Exports of Poland?
Ensure brevity in your answer.  7.33e+13. In the year 2013, what is the difference between the Exports of Japan and Exports of Russian Federation?
Offer a terse response. 6.77e+13. In the year 2013, what is the difference between the Exports in Kosovo and Exports in Poland?
Offer a terse response. -5.93e+11. In the year 2013, what is the difference between the Exports of Kosovo and Exports of Russian Federation?
Provide a succinct answer. -6.15e+12. In the year 2013, what is the difference between the Exports in Poland and Exports in Russian Federation?
Provide a short and direct response. -5.56e+12. What is the ratio of the Exports in Japan in 2006 to that in 2007?
Give a very brief answer. 0.92. What is the ratio of the Exports in Kosovo in 2006 to that in 2007?
Provide a short and direct response. 0.79. What is the ratio of the Exports of Poland in 2006 to that in 2007?
Make the answer very short. 0.91. What is the ratio of the Exports of Russian Federation in 2006 to that in 2007?
Offer a terse response. 0.94. What is the ratio of the Exports of Japan in 2006 to that in 2008?
Make the answer very short. 0.91. What is the ratio of the Exports in Kosovo in 2006 to that in 2008?
Your answer should be compact. 0.79. What is the ratio of the Exports in Poland in 2006 to that in 2008?
Your response must be concise. 0.85. What is the ratio of the Exports of Russian Federation in 2006 to that in 2008?
Your answer should be very brief. 0.94. What is the ratio of the Exports in Japan in 2006 to that in 2009?
Offer a terse response. 1.2. What is the ratio of the Exports of Kosovo in 2006 to that in 2009?
Give a very brief answer. 0.7. What is the ratio of the Exports in Poland in 2006 to that in 2009?
Provide a succinct answer. 0.9. What is the ratio of the Exports of Russian Federation in 2006 to that in 2009?
Provide a succinct answer. 0.98. What is the ratio of the Exports of Japan in 2006 to that in 2010?
Your answer should be very brief. 0.96. What is the ratio of the Exports of Kosovo in 2006 to that in 2010?
Ensure brevity in your answer.  0.62. What is the ratio of the Exports in Poland in 2006 to that in 2010?
Offer a very short reply. 0.8. What is the ratio of the Exports of Russian Federation in 2006 to that in 2010?
Your answer should be compact. 0.92. What is the ratio of the Exports of Japan in 2006 to that in 2011?
Your response must be concise. 0.97. What is the ratio of the Exports of Kosovo in 2006 to that in 2011?
Keep it short and to the point. 0.6. What is the ratio of the Exports in Poland in 2006 to that in 2011?
Offer a terse response. 0.74. What is the ratio of the Exports in Russian Federation in 2006 to that in 2011?
Your response must be concise. 0.91. What is the ratio of the Exports in Japan in 2006 to that in 2012?
Offer a very short reply. 0.97. What is the ratio of the Exports in Kosovo in 2006 to that in 2012?
Offer a terse response. 0.6. What is the ratio of the Exports of Poland in 2006 to that in 2012?
Your response must be concise. 0.71. What is the ratio of the Exports in Russian Federation in 2006 to that in 2012?
Offer a very short reply. 0.9. What is the ratio of the Exports in Japan in 2006 to that in 2013?
Your answer should be very brief. 0.95. What is the ratio of the Exports of Kosovo in 2006 to that in 2013?
Offer a very short reply. 0.58. What is the ratio of the Exports in Poland in 2006 to that in 2013?
Offer a very short reply. 0.67. What is the ratio of the Exports of Russian Federation in 2006 to that in 2013?
Offer a terse response. 0.86. What is the ratio of the Exports in Poland in 2007 to that in 2008?
Give a very brief answer. 0.93. What is the ratio of the Exports of Japan in 2007 to that in 2009?
Provide a short and direct response. 1.3. What is the ratio of the Exports in Kosovo in 2007 to that in 2009?
Your answer should be very brief. 0.89. What is the ratio of the Exports in Russian Federation in 2007 to that in 2009?
Keep it short and to the point. 1.04. What is the ratio of the Exports of Japan in 2007 to that in 2010?
Keep it short and to the point. 1.05. What is the ratio of the Exports of Kosovo in 2007 to that in 2010?
Your answer should be compact. 0.79. What is the ratio of the Exports in Poland in 2007 to that in 2010?
Keep it short and to the point. 0.88. What is the ratio of the Exports of Russian Federation in 2007 to that in 2010?
Provide a short and direct response. 0.97. What is the ratio of the Exports of Japan in 2007 to that in 2011?
Make the answer very short. 1.05. What is the ratio of the Exports of Kosovo in 2007 to that in 2011?
Your answer should be compact. 0.76. What is the ratio of the Exports in Poland in 2007 to that in 2011?
Provide a short and direct response. 0.82. What is the ratio of the Exports of Russian Federation in 2007 to that in 2011?
Your answer should be compact. 0.97. What is the ratio of the Exports of Japan in 2007 to that in 2012?
Provide a succinct answer. 1.05. What is the ratio of the Exports of Kosovo in 2007 to that in 2012?
Your answer should be compact. 0.76. What is the ratio of the Exports in Poland in 2007 to that in 2012?
Provide a short and direct response. 0.78. What is the ratio of the Exports in Russian Federation in 2007 to that in 2012?
Ensure brevity in your answer.  0.96. What is the ratio of the Exports in Japan in 2007 to that in 2013?
Your answer should be very brief. 1.04. What is the ratio of the Exports of Kosovo in 2007 to that in 2013?
Keep it short and to the point. 0.74. What is the ratio of the Exports in Poland in 2007 to that in 2013?
Your answer should be compact. 0.74. What is the ratio of the Exports in Russian Federation in 2007 to that in 2013?
Offer a very short reply. 0.92. What is the ratio of the Exports in Japan in 2008 to that in 2009?
Offer a terse response. 1.32. What is the ratio of the Exports of Kosovo in 2008 to that in 2009?
Make the answer very short. 0.89. What is the ratio of the Exports of Poland in 2008 to that in 2009?
Your response must be concise. 1.07. What is the ratio of the Exports of Russian Federation in 2008 to that in 2009?
Give a very brief answer. 1.05. What is the ratio of the Exports of Japan in 2008 to that in 2010?
Provide a short and direct response. 1.06. What is the ratio of the Exports in Kosovo in 2008 to that in 2010?
Ensure brevity in your answer.  0.79. What is the ratio of the Exports in Poland in 2008 to that in 2010?
Offer a very short reply. 0.95. What is the ratio of the Exports in Russian Federation in 2008 to that in 2010?
Keep it short and to the point. 0.98. What is the ratio of the Exports of Japan in 2008 to that in 2011?
Provide a short and direct response. 1.06. What is the ratio of the Exports in Kosovo in 2008 to that in 2011?
Keep it short and to the point. 0.76. What is the ratio of the Exports of Poland in 2008 to that in 2011?
Give a very brief answer. 0.88. What is the ratio of the Exports of Russian Federation in 2008 to that in 2011?
Keep it short and to the point. 0.98. What is the ratio of the Exports of Japan in 2008 to that in 2012?
Your answer should be very brief. 1.07. What is the ratio of the Exports in Kosovo in 2008 to that in 2012?
Your answer should be very brief. 0.76. What is the ratio of the Exports of Poland in 2008 to that in 2012?
Ensure brevity in your answer.  0.84. What is the ratio of the Exports of Russian Federation in 2008 to that in 2012?
Provide a succinct answer. 0.97. What is the ratio of the Exports of Japan in 2008 to that in 2013?
Offer a very short reply. 1.05. What is the ratio of the Exports of Kosovo in 2008 to that in 2013?
Offer a terse response. 0.74. What is the ratio of the Exports in Poland in 2008 to that in 2013?
Ensure brevity in your answer.  0.79. What is the ratio of the Exports in Russian Federation in 2008 to that in 2013?
Your response must be concise. 0.92. What is the ratio of the Exports of Japan in 2009 to that in 2010?
Keep it short and to the point. 0.8. What is the ratio of the Exports of Kosovo in 2009 to that in 2010?
Make the answer very short. 0.89. What is the ratio of the Exports of Poland in 2009 to that in 2010?
Make the answer very short. 0.89. What is the ratio of the Exports in Russian Federation in 2009 to that in 2010?
Offer a terse response. 0.93. What is the ratio of the Exports in Japan in 2009 to that in 2011?
Provide a short and direct response. 0.81. What is the ratio of the Exports in Kosovo in 2009 to that in 2011?
Your answer should be compact. 0.86. What is the ratio of the Exports of Poland in 2009 to that in 2011?
Your answer should be very brief. 0.82. What is the ratio of the Exports of Russian Federation in 2009 to that in 2011?
Ensure brevity in your answer.  0.93. What is the ratio of the Exports in Japan in 2009 to that in 2012?
Your response must be concise. 0.81. What is the ratio of the Exports in Poland in 2009 to that in 2012?
Offer a terse response. 0.79. What is the ratio of the Exports of Russian Federation in 2009 to that in 2012?
Ensure brevity in your answer.  0.92. What is the ratio of the Exports in Japan in 2009 to that in 2013?
Keep it short and to the point. 0.8. What is the ratio of the Exports in Kosovo in 2009 to that in 2013?
Keep it short and to the point. 0.83. What is the ratio of the Exports in Poland in 2009 to that in 2013?
Your answer should be very brief. 0.74. What is the ratio of the Exports of Russian Federation in 2009 to that in 2013?
Keep it short and to the point. 0.88. What is the ratio of the Exports of Poland in 2010 to that in 2011?
Offer a terse response. 0.93. What is the ratio of the Exports of Russian Federation in 2010 to that in 2011?
Keep it short and to the point. 1. What is the ratio of the Exports of Japan in 2010 to that in 2012?
Your response must be concise. 1.01. What is the ratio of the Exports in Kosovo in 2010 to that in 2012?
Make the answer very short. 0.96. What is the ratio of the Exports of Poland in 2010 to that in 2012?
Provide a succinct answer. 0.89. What is the ratio of the Exports in Russian Federation in 2010 to that in 2012?
Offer a terse response. 0.99. What is the ratio of the Exports of Japan in 2010 to that in 2013?
Your response must be concise. 0.99. What is the ratio of the Exports in Kosovo in 2010 to that in 2013?
Offer a very short reply. 0.93. What is the ratio of the Exports in Poland in 2010 to that in 2013?
Keep it short and to the point. 0.84. What is the ratio of the Exports in Russian Federation in 2010 to that in 2013?
Your response must be concise. 0.94. What is the ratio of the Exports of Japan in 2011 to that in 2012?
Offer a terse response. 1. What is the ratio of the Exports in Kosovo in 2011 to that in 2012?
Provide a succinct answer. 0.99. What is the ratio of the Exports in Poland in 2011 to that in 2012?
Make the answer very short. 0.96. What is the ratio of the Exports in Russian Federation in 2011 to that in 2012?
Offer a very short reply. 0.99. What is the ratio of the Exports in Japan in 2011 to that in 2013?
Give a very brief answer. 0.99. What is the ratio of the Exports of Kosovo in 2011 to that in 2013?
Make the answer very short. 0.97. What is the ratio of the Exports in Poland in 2011 to that in 2013?
Keep it short and to the point. 0.9. What is the ratio of the Exports in Russian Federation in 2011 to that in 2013?
Your response must be concise. 0.95. What is the ratio of the Exports in Japan in 2012 to that in 2013?
Your response must be concise. 0.98. What is the ratio of the Exports of Kosovo in 2012 to that in 2013?
Offer a very short reply. 0.98. What is the ratio of the Exports of Poland in 2012 to that in 2013?
Provide a short and direct response. 0.94. What is the ratio of the Exports of Russian Federation in 2012 to that in 2013?
Provide a succinct answer. 0.96. What is the difference between the highest and the second highest Exports in Japan?
Make the answer very short. 1.08e+12. What is the difference between the highest and the second highest Exports of Kosovo?
Keep it short and to the point. 1.86e+07. What is the difference between the highest and the second highest Exports of Poland?
Offer a terse response. 3.41e+1. What is the difference between the highest and the second highest Exports of Russian Federation?
Your answer should be very brief. 2.71e+11. What is the difference between the highest and the lowest Exports in Japan?
Ensure brevity in your answer.  1.88e+13. What is the difference between the highest and the lowest Exports in Kosovo?
Provide a short and direct response. 3.43e+08. What is the difference between the highest and the lowest Exports in Poland?
Keep it short and to the point. 1.96e+11. What is the difference between the highest and the lowest Exports in Russian Federation?
Provide a short and direct response. 8.34e+11. 